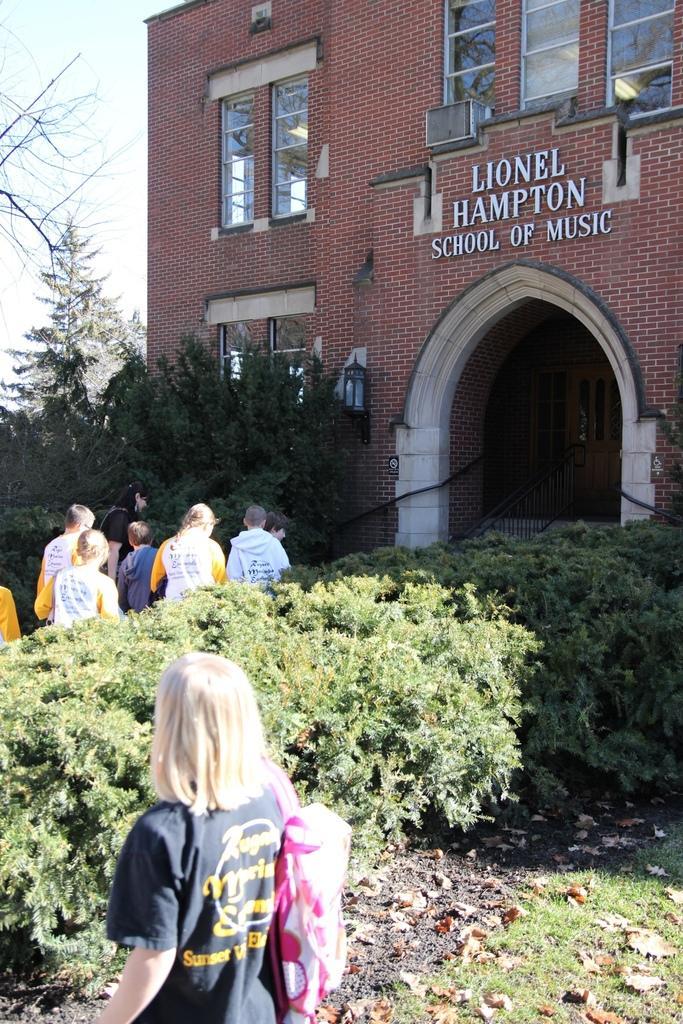How would you summarize this image in a sentence or two? In this picture we can observe some people. There is a girl holding a pink color bag on her shoulders. We can observe some plants. There are trees. There is a brown color building. In the background there is a sky. 